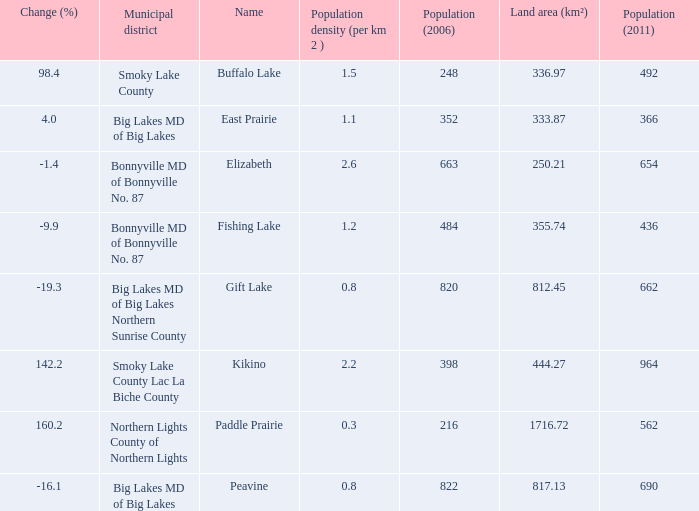What is the population density in Buffalo Lake? 1.5. Parse the full table. {'header': ['Change (%)', 'Municipal district', 'Name', 'Population density (per km 2 )', 'Population (2006)', 'Land area (km²)', 'Population (2011)'], 'rows': [['98.4', 'Smoky Lake County', 'Buffalo Lake', '1.5', '248', '336.97', '492'], ['4.0', 'Big Lakes MD of Big Lakes', 'East Prairie', '1.1', '352', '333.87', '366'], ['-1.4', 'Bonnyville MD of Bonnyville No. 87', 'Elizabeth', '2.6', '663', '250.21', '654'], ['-9.9', 'Bonnyville MD of Bonnyville No. 87', 'Fishing Lake', '1.2', '484', '355.74', '436'], ['-19.3', 'Big Lakes MD of Big Lakes Northern Sunrise County', 'Gift Lake', '0.8', '820', '812.45', '662'], ['142.2', 'Smoky Lake County Lac La Biche County', 'Kikino', '2.2', '398', '444.27', '964'], ['160.2', 'Northern Lights County of Northern Lights', 'Paddle Prairie', '0.3', '216', '1716.72', '562'], ['-16.1', 'Big Lakes MD of Big Lakes', 'Peavine', '0.8', '822', '817.13', '690']]} 